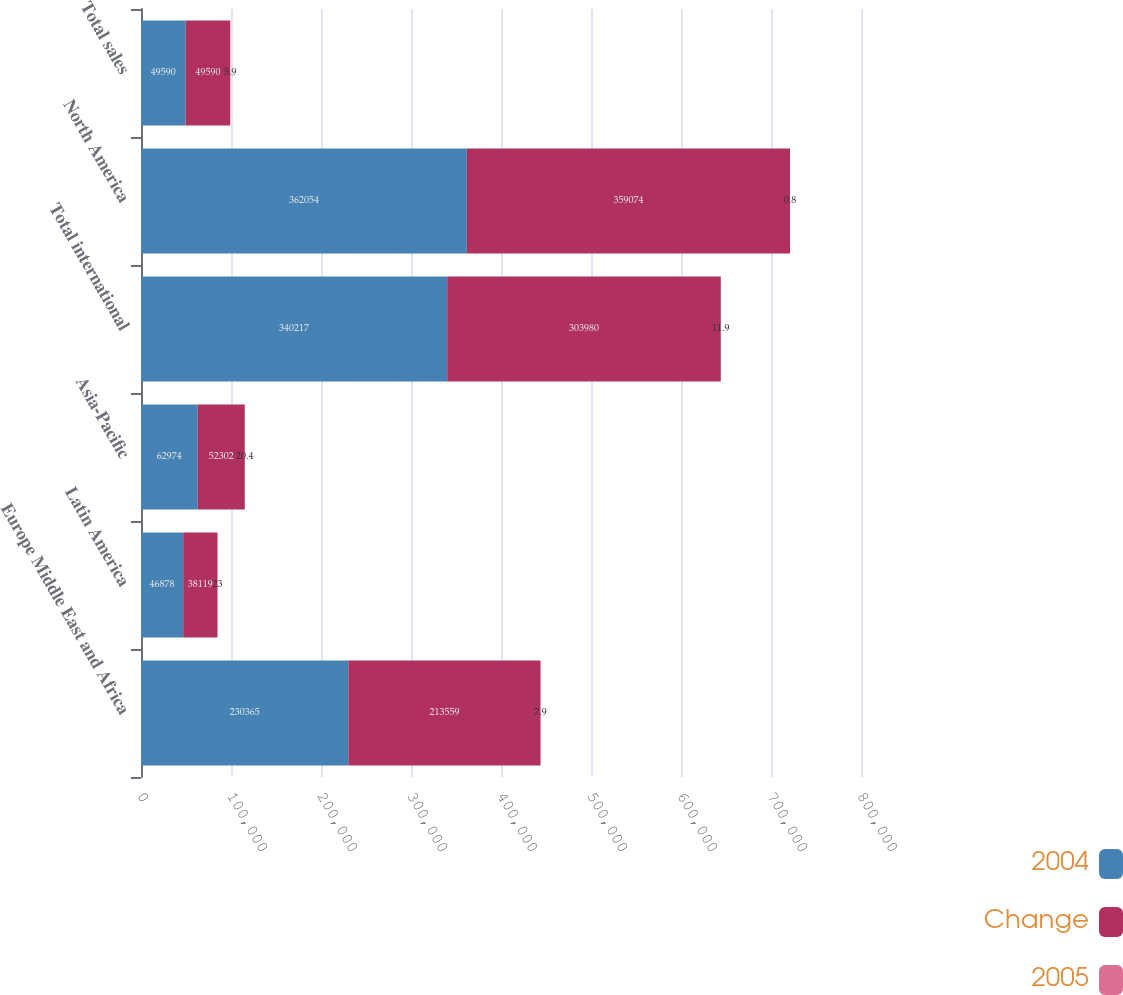<chart> <loc_0><loc_0><loc_500><loc_500><stacked_bar_chart><ecel><fcel>Europe Middle East and Africa<fcel>Latin America<fcel>Asia-Pacific<fcel>Total international<fcel>North America<fcel>Total sales<nl><fcel>2004<fcel>230365<fcel>46878<fcel>62974<fcel>340217<fcel>362054<fcel>49590<nl><fcel>Change<fcel>213559<fcel>38119<fcel>52302<fcel>303980<fcel>359074<fcel>49590<nl><fcel>2005<fcel>7.9<fcel>23<fcel>20.4<fcel>11.9<fcel>0.8<fcel>5.9<nl></chart> 